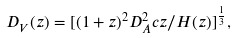<formula> <loc_0><loc_0><loc_500><loc_500>D _ { V } ( z ) = [ ( 1 + z ) ^ { 2 } D ^ { 2 } _ { A } c z / H ( z ) ] ^ { \frac { 1 } { 3 } } ,</formula> 